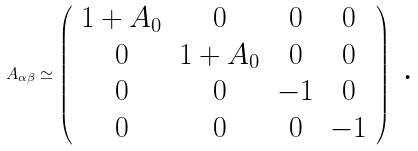<formula> <loc_0><loc_0><loc_500><loc_500>A _ { \alpha \beta } \simeq \left ( \begin{array} { c c c c } 1 + A _ { 0 } & 0 & 0 & 0 \\ 0 & 1 + A _ { 0 } & 0 & 0 \\ 0 & 0 & - 1 & 0 \\ 0 & 0 & 0 & - 1 \end{array} \right ) \text { .}</formula> 